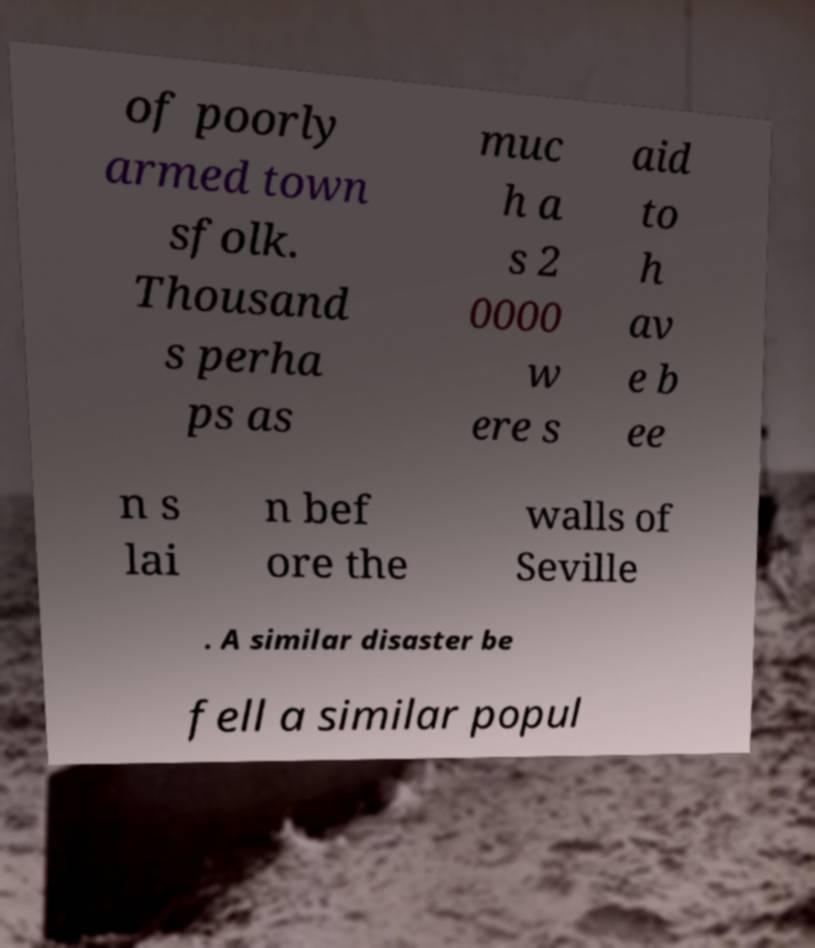I need the written content from this picture converted into text. Can you do that? of poorly armed town sfolk. Thousand s perha ps as muc h a s 2 0000 w ere s aid to h av e b ee n s lai n bef ore the walls of Seville . A similar disaster be fell a similar popul 